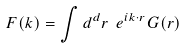<formula> <loc_0><loc_0><loc_500><loc_500>F ( { k } ) = \int d ^ { d } r \ e ^ { i k \cdot r } G ( { r } )</formula> 